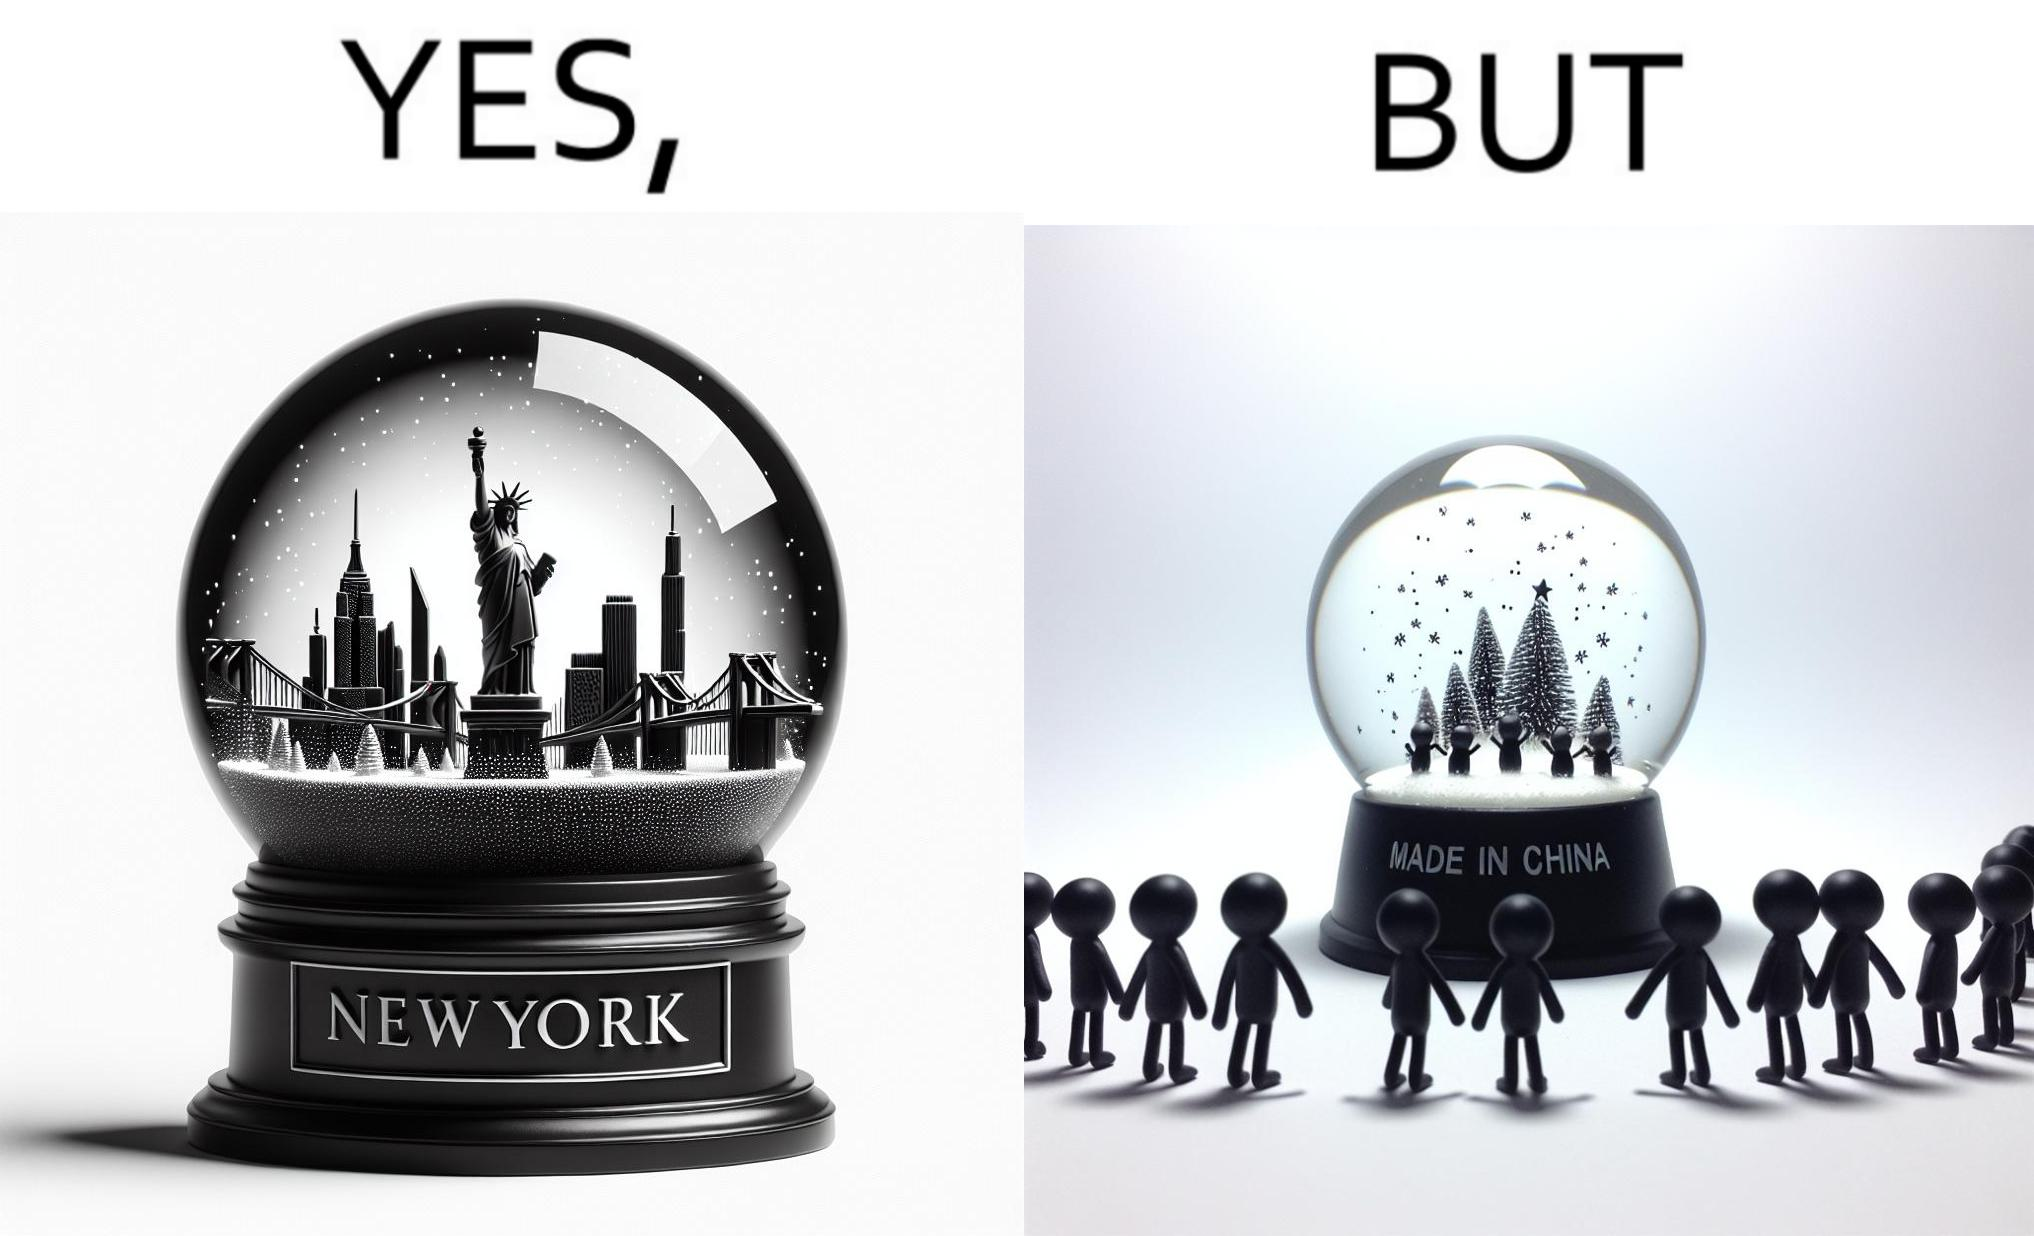Is this a satirical image? Yes, this image is satirical. 